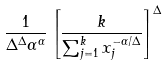<formula> <loc_0><loc_0><loc_500><loc_500>\frac { 1 } { \Delta ^ { \Delta } \alpha ^ { \alpha } } \left [ \frac { k } { \sum _ { j = 1 } ^ { k } x _ { j } ^ { - \alpha / \Delta } } \right ] ^ { \Delta }</formula> 